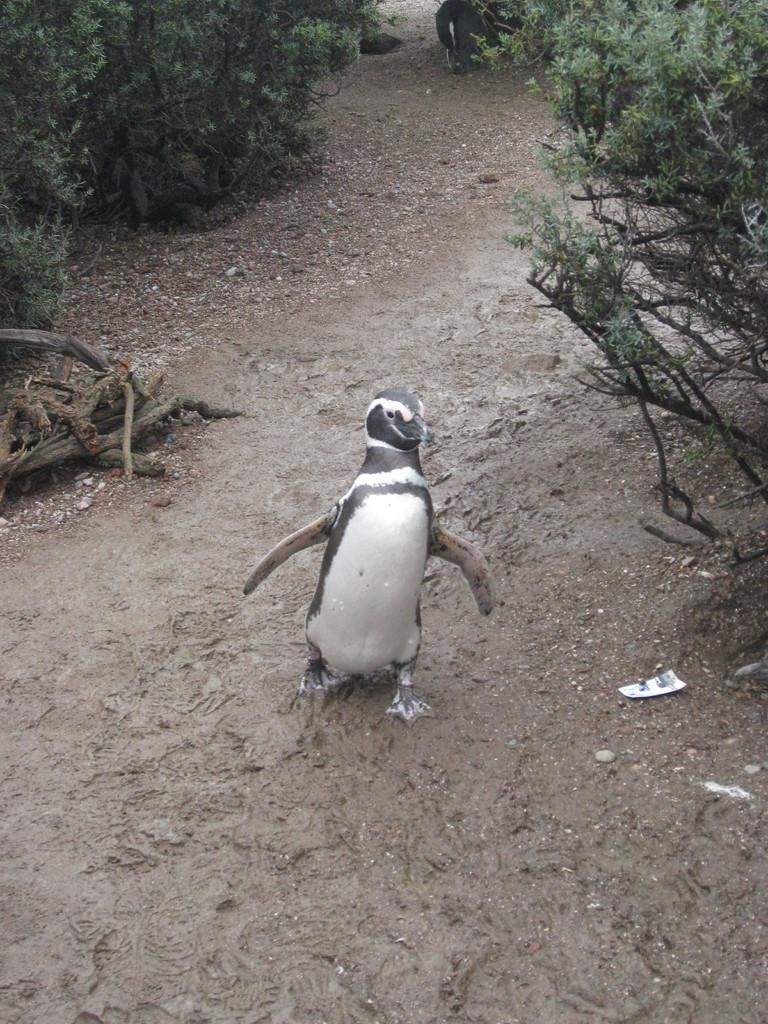How would you summarize this image in a sentence or two? In this image, we can see a penguin is walking in the mud. Top of the image, we can see few plants. 